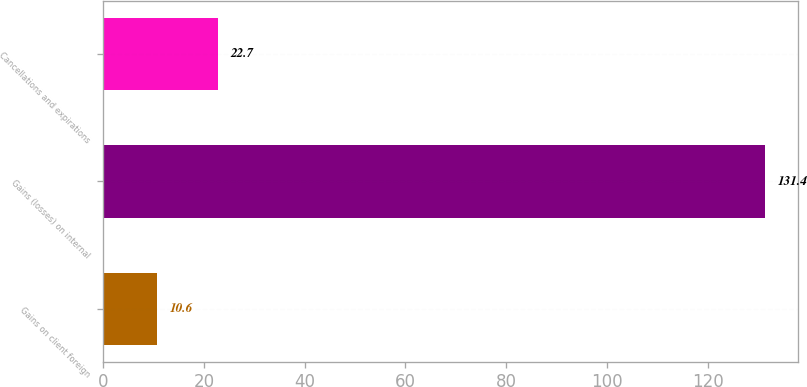Convert chart to OTSL. <chart><loc_0><loc_0><loc_500><loc_500><bar_chart><fcel>Gains on client foreign<fcel>Gains (losses) on internal<fcel>Cancellations and expirations<nl><fcel>10.6<fcel>131.4<fcel>22.7<nl></chart> 